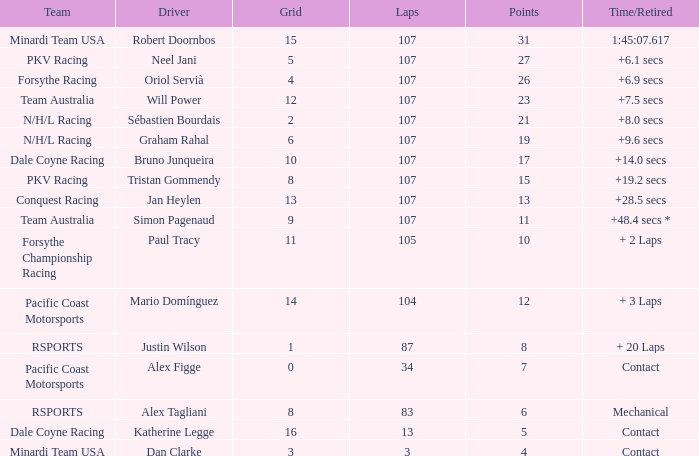I'm looking to parse the entire table for insights. Could you assist me with that? {'header': ['Team', 'Driver', 'Grid', 'Laps', 'Points', 'Time/Retired'], 'rows': [['Minardi Team USA', 'Robert Doornbos', '15', '107', '31', '1:45:07.617'], ['PKV Racing', 'Neel Jani', '5', '107', '27', '+6.1 secs'], ['Forsythe Racing', 'Oriol Servià', '4', '107', '26', '+6.9 secs'], ['Team Australia', 'Will Power', '12', '107', '23', '+7.5 secs'], ['N/H/L Racing', 'Sébastien Bourdais', '2', '107', '21', '+8.0 secs'], ['N/H/L Racing', 'Graham Rahal', '6', '107', '19', '+9.6 secs'], ['Dale Coyne Racing', 'Bruno Junqueira', '10', '107', '17', '+14.0 secs'], ['PKV Racing', 'Tristan Gommendy', '8', '107', '15', '+19.2 secs'], ['Conquest Racing', 'Jan Heylen', '13', '107', '13', '+28.5 secs'], ['Team Australia', 'Simon Pagenaud', '9', '107', '11', '+48.4 secs *'], ['Forsythe Championship Racing', 'Paul Tracy', '11', '105', '10', '+ 2 Laps'], ['Pacific Coast Motorsports', 'Mario Domínguez', '14', '104', '12', '+ 3 Laps'], ['RSPORTS', 'Justin Wilson', '1', '87', '8', '+ 20 Laps'], ['Pacific Coast Motorsports', 'Alex Figge', '0', '34', '7', 'Contact'], ['RSPORTS', 'Alex Tagliani', '8', '83', '6', 'Mechanical'], ['Dale Coyne Racing', 'Katherine Legge', '16', '13', '5', 'Contact'], ['Minardi Team USA', 'Dan Clarke', '3', '3', '4', 'Contact']]} What is mario domínguez's average Grid? 14.0. 